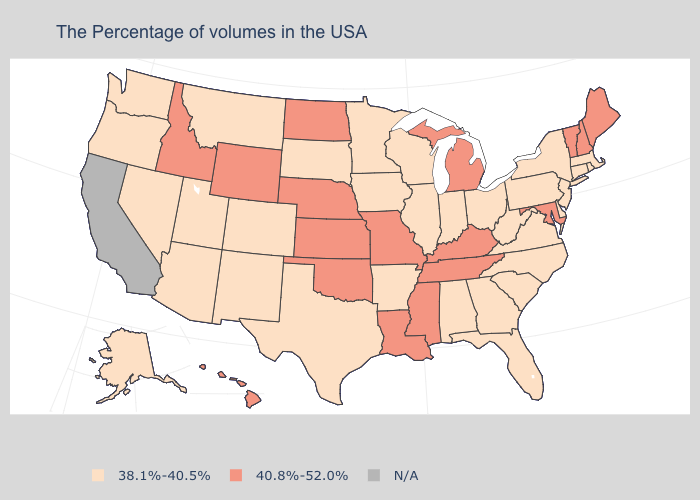What is the highest value in states that border New Jersey?
Keep it brief. 38.1%-40.5%. What is the value of Colorado?
Concise answer only. 38.1%-40.5%. Does the first symbol in the legend represent the smallest category?
Be succinct. Yes. Which states hav the highest value in the South?
Give a very brief answer. Maryland, Kentucky, Tennessee, Mississippi, Louisiana, Oklahoma. What is the value of Ohio?
Concise answer only. 38.1%-40.5%. What is the value of Oklahoma?
Be succinct. 40.8%-52.0%. What is the lowest value in states that border Vermont?
Be succinct. 38.1%-40.5%. Among the states that border South Carolina , which have the lowest value?
Concise answer only. North Carolina, Georgia. Name the states that have a value in the range 38.1%-40.5%?
Give a very brief answer. Massachusetts, Rhode Island, Connecticut, New York, New Jersey, Delaware, Pennsylvania, Virginia, North Carolina, South Carolina, West Virginia, Ohio, Florida, Georgia, Indiana, Alabama, Wisconsin, Illinois, Arkansas, Minnesota, Iowa, Texas, South Dakota, Colorado, New Mexico, Utah, Montana, Arizona, Nevada, Washington, Oregon, Alaska. Among the states that border Rhode Island , which have the lowest value?
Keep it brief. Massachusetts, Connecticut. Name the states that have a value in the range 38.1%-40.5%?
Short answer required. Massachusetts, Rhode Island, Connecticut, New York, New Jersey, Delaware, Pennsylvania, Virginia, North Carolina, South Carolina, West Virginia, Ohio, Florida, Georgia, Indiana, Alabama, Wisconsin, Illinois, Arkansas, Minnesota, Iowa, Texas, South Dakota, Colorado, New Mexico, Utah, Montana, Arizona, Nevada, Washington, Oregon, Alaska. What is the value of Nevada?
Answer briefly. 38.1%-40.5%. Name the states that have a value in the range N/A?
Quick response, please. California. Name the states that have a value in the range N/A?
Give a very brief answer. California. 